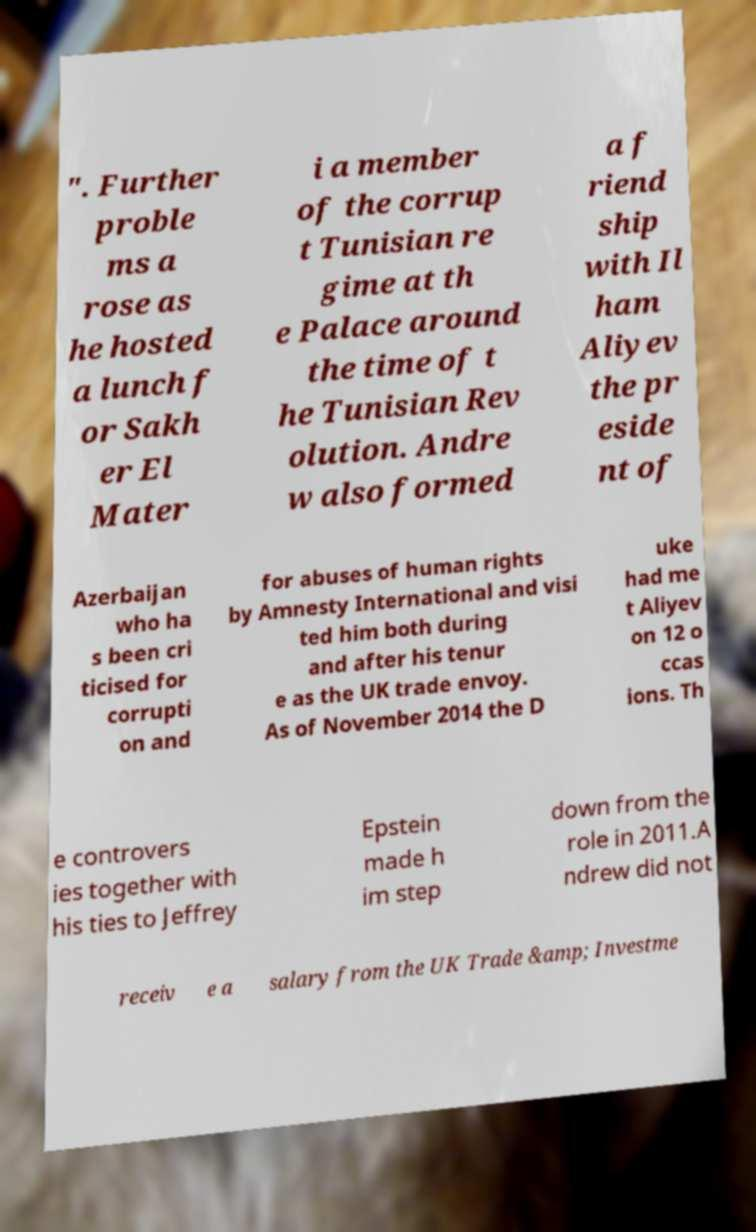For documentation purposes, I need the text within this image transcribed. Could you provide that? ". Further proble ms a rose as he hosted a lunch f or Sakh er El Mater i a member of the corrup t Tunisian re gime at th e Palace around the time of t he Tunisian Rev olution. Andre w also formed a f riend ship with Il ham Aliyev the pr eside nt of Azerbaijan who ha s been cri ticised for corrupti on and for abuses of human rights by Amnesty International and visi ted him both during and after his tenur e as the UK trade envoy. As of November 2014 the D uke had me t Aliyev on 12 o ccas ions. Th e controvers ies together with his ties to Jeffrey Epstein made h im step down from the role in 2011.A ndrew did not receiv e a salary from the UK Trade &amp; Investme 